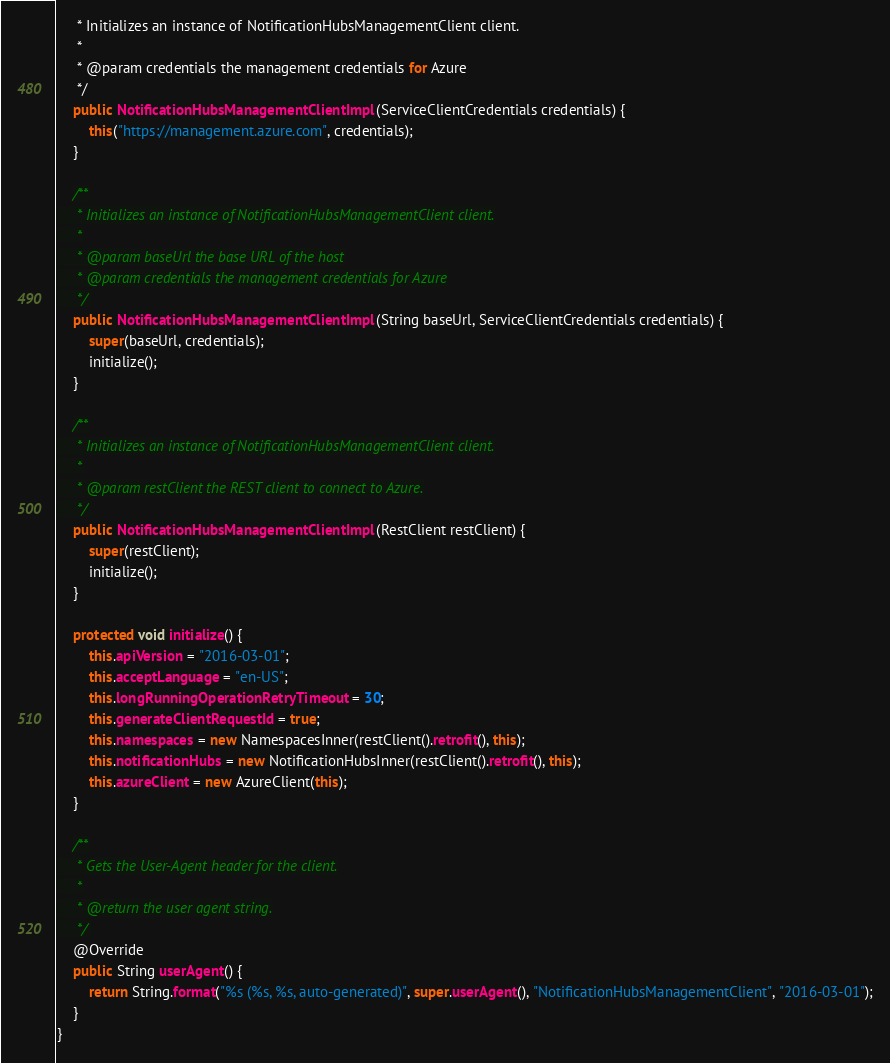<code> <loc_0><loc_0><loc_500><loc_500><_Java_>     * Initializes an instance of NotificationHubsManagementClient client.
     *
     * @param credentials the management credentials for Azure
     */
    public NotificationHubsManagementClientImpl(ServiceClientCredentials credentials) {
        this("https://management.azure.com", credentials);
    }

    /**
     * Initializes an instance of NotificationHubsManagementClient client.
     *
     * @param baseUrl the base URL of the host
     * @param credentials the management credentials for Azure
     */
    public NotificationHubsManagementClientImpl(String baseUrl, ServiceClientCredentials credentials) {
        super(baseUrl, credentials);
        initialize();
    }

    /**
     * Initializes an instance of NotificationHubsManagementClient client.
     *
     * @param restClient the REST client to connect to Azure.
     */
    public NotificationHubsManagementClientImpl(RestClient restClient) {
        super(restClient);
        initialize();
    }

    protected void initialize() {
        this.apiVersion = "2016-03-01";
        this.acceptLanguage = "en-US";
        this.longRunningOperationRetryTimeout = 30;
        this.generateClientRequestId = true;
        this.namespaces = new NamespacesInner(restClient().retrofit(), this);
        this.notificationHubs = new NotificationHubsInner(restClient().retrofit(), this);
        this.azureClient = new AzureClient(this);
    }

    /**
     * Gets the User-Agent header for the client.
     *
     * @return the user agent string.
     */
    @Override
    public String userAgent() {
        return String.format("%s (%s, %s, auto-generated)", super.userAgent(), "NotificationHubsManagementClient", "2016-03-01");
    }
}
</code> 